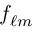<formula> <loc_0><loc_0><loc_500><loc_500>f _ { \ell m }</formula> 